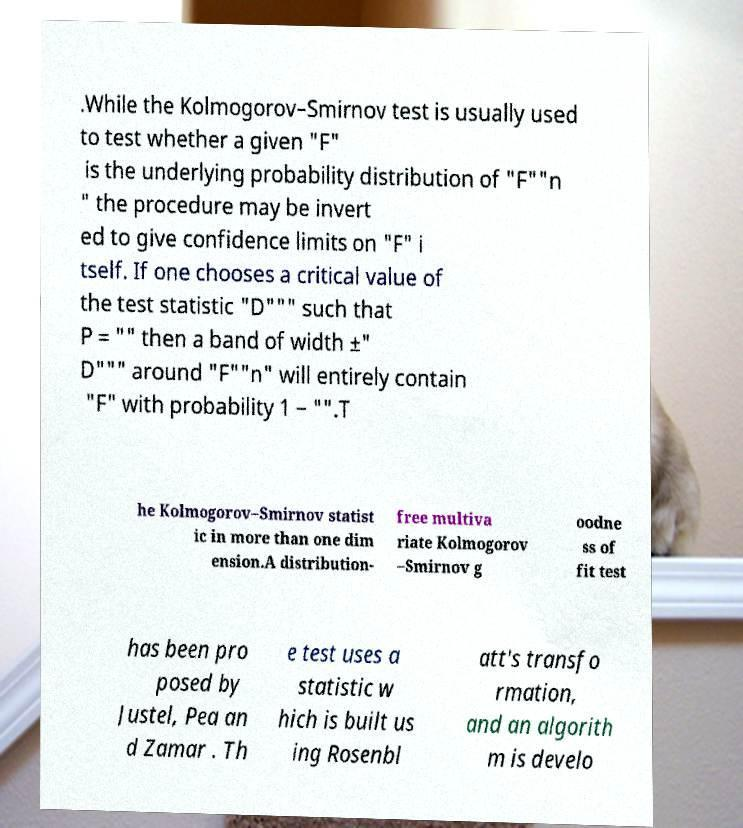Can you accurately transcribe the text from the provided image for me? .While the Kolmogorov–Smirnov test is usually used to test whether a given "F" is the underlying probability distribution of "F""n " the procedure may be invert ed to give confidence limits on "F" i tself. If one chooses a critical value of the test statistic "D""" such that P = "" then a band of width ±" D""" around "F""n" will entirely contain "F" with probability 1 − "".T he Kolmogorov–Smirnov statist ic in more than one dim ension.A distribution- free multiva riate Kolmogorov –Smirnov g oodne ss of fit test has been pro posed by Justel, Pea an d Zamar . Th e test uses a statistic w hich is built us ing Rosenbl att's transfo rmation, and an algorith m is develo 